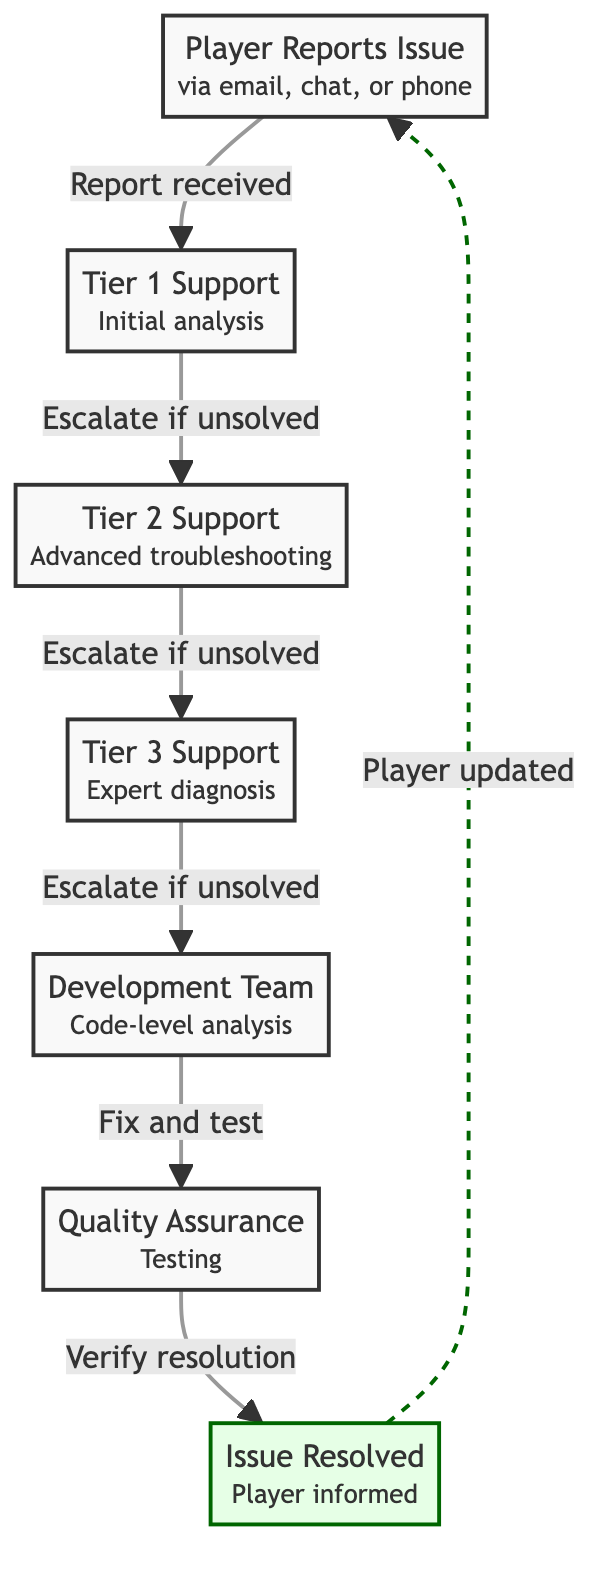What's the first step in the escalation process? The first step in the escalation process is when the player reports an issue. This is represented by the node labeled "Player Reports Issue."
Answer: Player Reports Issue How many tiers of support are involved in the process? The diagram shows a total of three tiers of support, specifically Tier 1, Tier 2, and Tier 3.
Answer: Three What does Tier 2 Support do? Tier 2 Support is responsible for advanced troubleshooting as indicated on the diagram.
Answer: Advanced troubleshooting What happens after the Development Team fixes the issue? After the Development Team fixes the issue, the Quality Assurance team is tasked with testing the solution to verify its functionality. This is represented in the flow from the Development Team to the Quality Assurance node.
Answer: Testing Which node indicates that the issue has been resolved? The "Issue Resolved" node clearly indicates that the problem has been resolved, as it is highlighted in green, suggesting a successful outcome.
Answer: Issue Resolved If the issue is not resolved at Tier 1, where does it go next? If the issue is not resolved at Tier 1, it is escalated to Tier 2 Support, as indicated by the arrow connecting the two nodes.
Answer: Tier 2 Support What role does Quality Assurance play in the process? The role of Quality Assurance is to verify the resolution after testing the fixes provided by the Development Team. This is clarified in the connection from the Development Team to Quality Assurance that follows the fix.
Answer: Verify resolution How are players updated after the issue is resolved? Players are updated through a dashed line that connects back to the "Player Reports Issue" node, indicating that once the issue is resolved, communication is made to inform the player.
Answer: Player updated What is the relationship between Tier 4 and the process? There is no direct mention of a Tier 4 in this escalation process. The highest level of escalation is the Development Team, indicating Tiers 1 to 3 are the only support levels illustrated.
Answer: None 